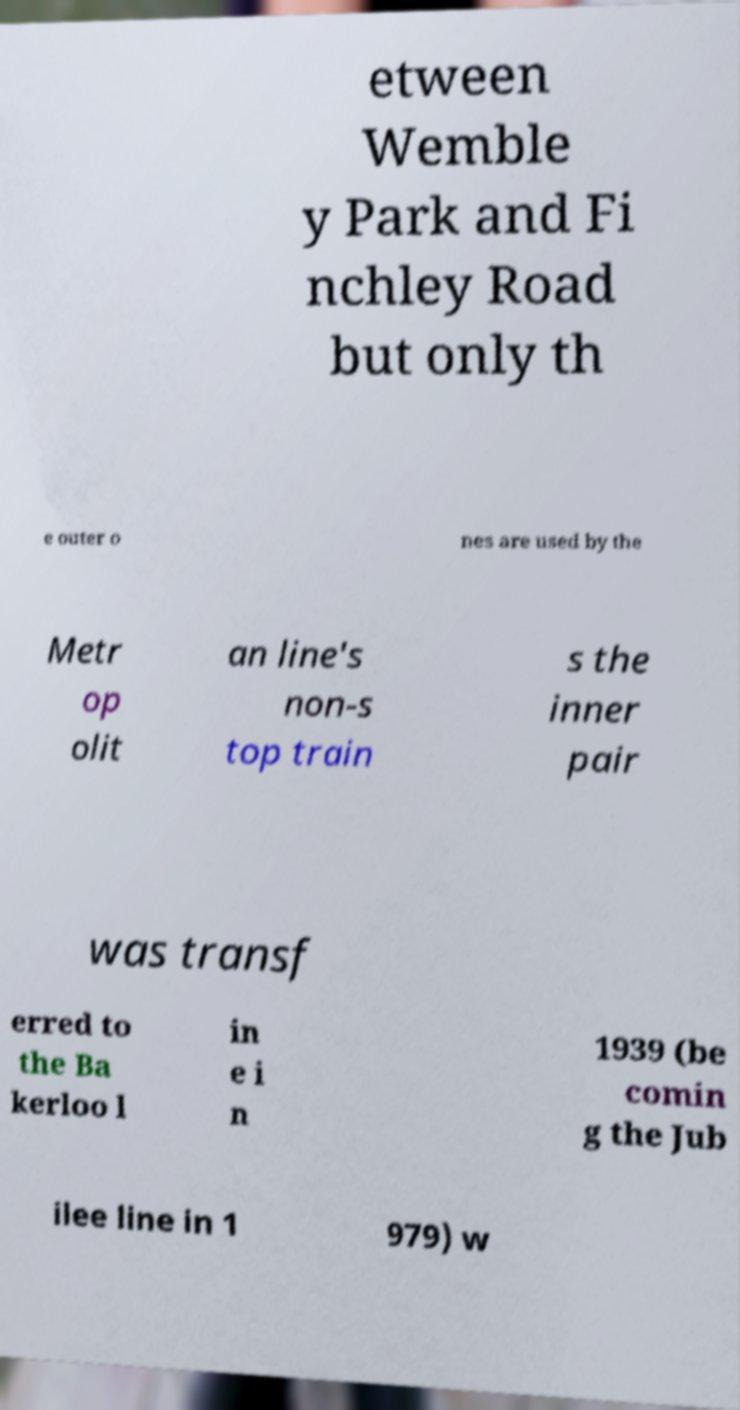Could you assist in decoding the text presented in this image and type it out clearly? etween Wemble y Park and Fi nchley Road but only th e outer o nes are used by the Metr op olit an line's non-s top train s the inner pair was transf erred to the Ba kerloo l in e i n 1939 (be comin g the Jub ilee line in 1 979) w 